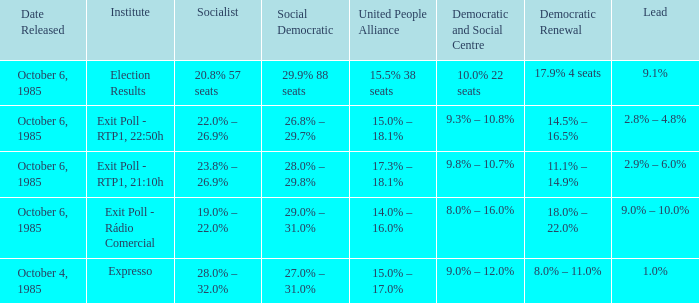0% – 2 Exit Poll - Rádio Comercial. 